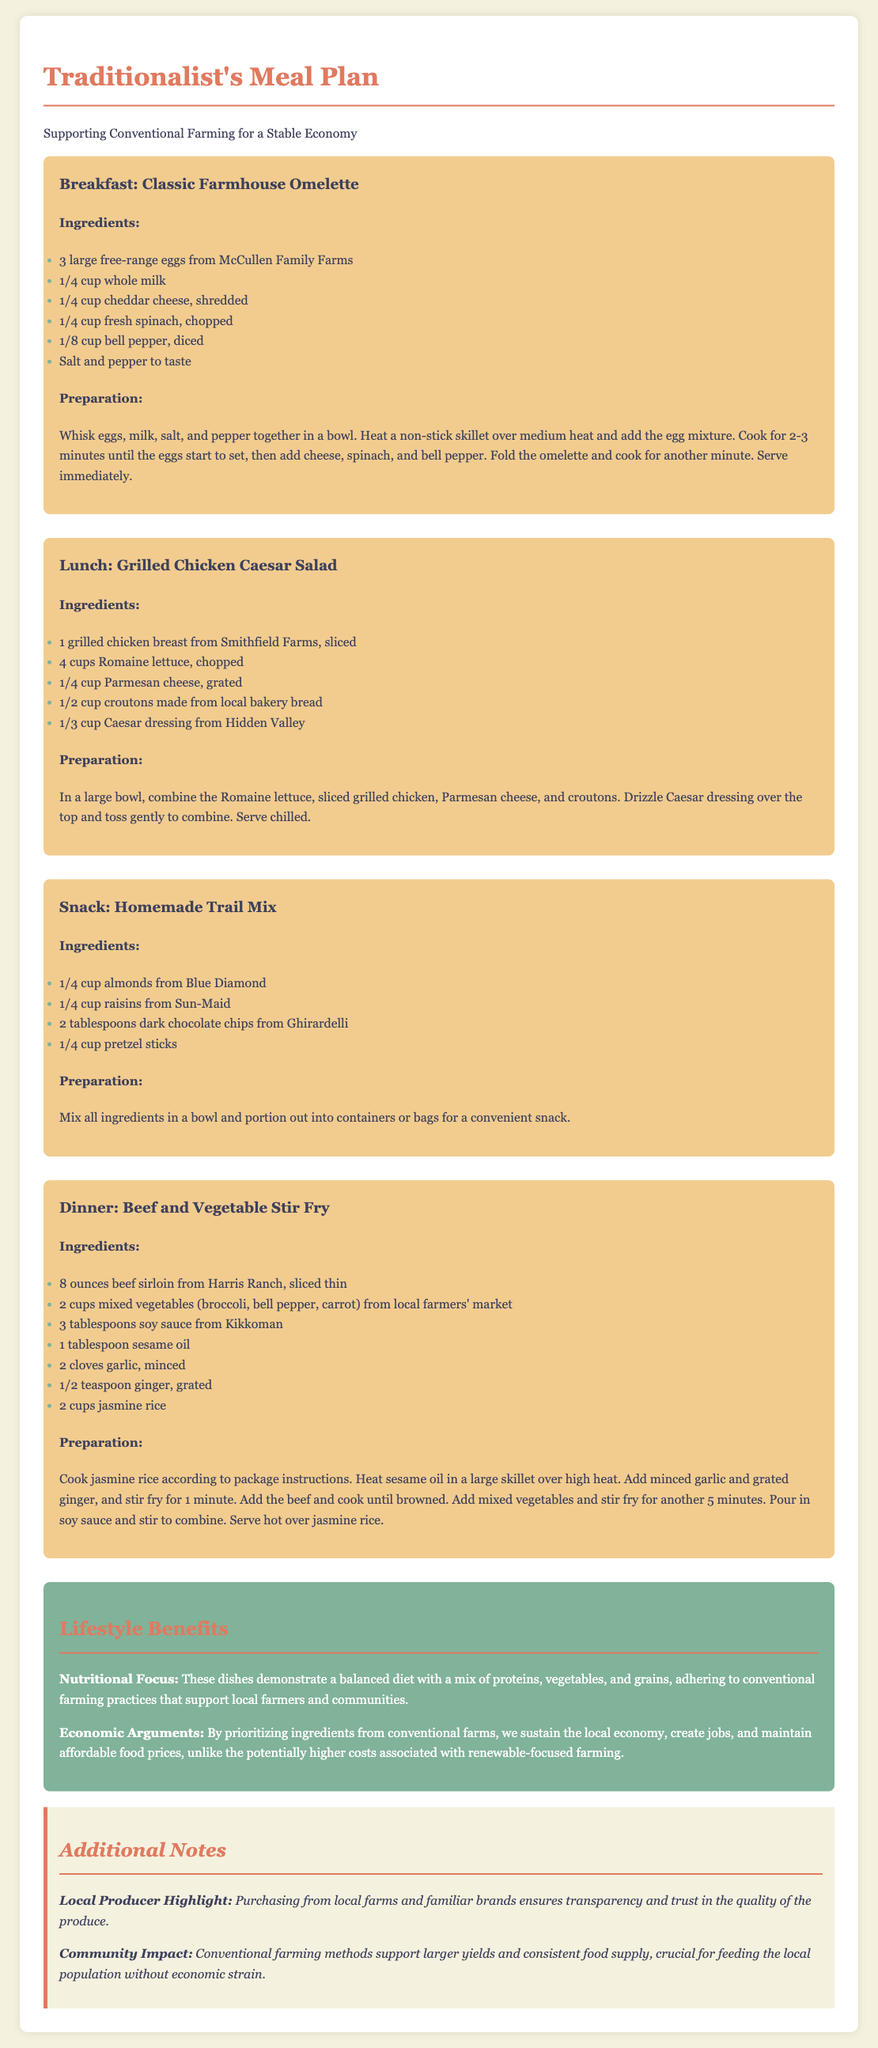What is the primary focus of the meal plan? The primary focus of the meal plan is to support conventional farming for a stable economy.
Answer: conventional farming Who provides the eggs for the breakfast recipe? The breakfast recipe mentions eggs from McCullen Family Farms.
Answer: McCullen Family Farms What type of cheese is used in the breakfast omelette? The breakfast omelette uses cheddar cheese, as specified in the ingredients list.
Answer: cheddar cheese How many cups of Romaine lettuce are needed for the lunch salad? The lunch salad requires 4 cups of Romaine lettuce according to the ingredients.
Answer: 4 cups What is a benefit mentioned regarding conventional farming in the meal plan? The meal plan states that prioritizing ingredients from conventional farms sustains the local economy.
Answer: sustains the local economy How much beef sirloin is included in the dinner recipe? The dinner recipe includes 8 ounces of beef sirloin.
Answer: 8 ounces What is a key lifestyle benefit of the meal plan? One key lifestyle benefit is a balanced diet with a mix of proteins, vegetables, and grains.
Answer: balanced diet What are the two main ingredients in the homemade trail mix? The two main ingredients in the homemade trail mix are almonds and raisins.
Answer: almonds and raisins What type of oil is used in the dinner stir-fry recipe? The dinner stir-fry recipe uses sesame oil.
Answer: sesame oil 